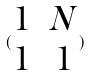<formula> <loc_0><loc_0><loc_500><loc_500>( \begin{matrix} 1 & N \\ 1 & 1 \end{matrix} )</formula> 